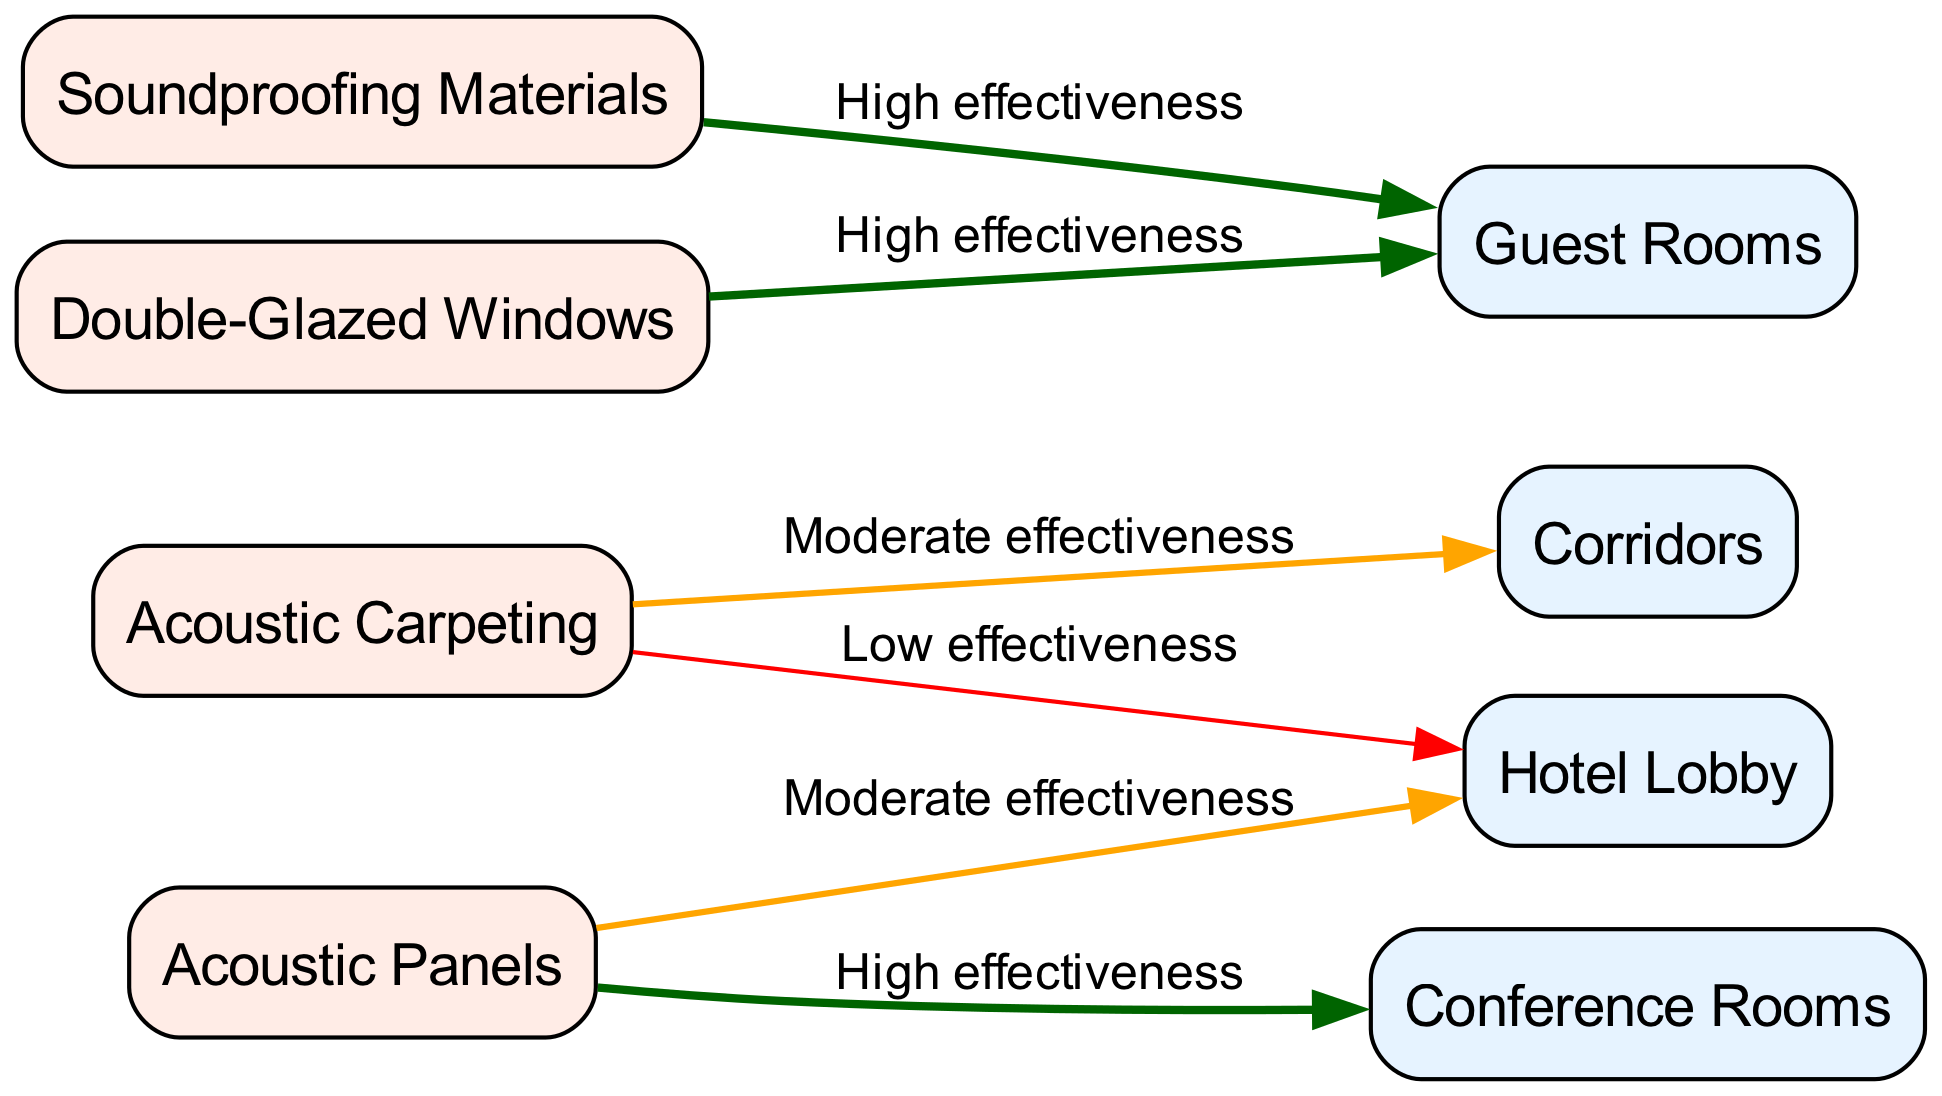What are the areas in the hotel represented in the diagram? The diagram includes the following nodes representing areas in the hotel: lobby, guestrooms, corridors, and conference rooms.
Answer: lobby, guestrooms, corridors, conference rooms Which acoustic treatment has high effectiveness for guestrooms? In the diagram, both soundproofing materials and double-glazed windows lead to guestrooms with a label indicating high effectiveness.
Answer: Soundproofing materials, Double-Glazed Windows How many edges connect acoustic treatments and hotel areas? The diagram shows a total of five edges connecting different acoustic treatments to hotel areas.
Answer: Five What is the effectiveness level of acoustic carpeting in corridors? The edge connecting acoustic carpeting to corridors is labeled with moderate effectiveness, indicating the level of insulation provided.
Answer: Moderate effectiveness Which treatment shows low effectiveness in the lobby area? The edge connecting carpeting to the lobby is labeled with low effectiveness, reflecting its limited noise insulation capabilities.
Answer: Low effectiveness What is the relationship between acoustic panels and conference rooms? The edge from acoustic panels to conference rooms indicates a high effectiveness, suggesting that these panels are particularly effective in reducing noise in that area.
Answer: High effectiveness How many treatments show high effectiveness in the diagram? There are three treatments in the diagram that show high effectiveness: soundproofing materials, double-glazed windows, and acoustic panels to conference rooms.
Answer: Three Which area benefits the least from acoustic carpeting? The edge from carpeting to the lobby indicates low effectiveness, suggesting that it provides the least noise insulation in that area compared to others.
Answer: Lobby Which type of windows is mentioned for their high effectiveness in guestrooms? The diagram highlights double-glazed windows as a treatment that has high effectiveness specifically for guestrooms.
Answer: Double-Glazed Windows 